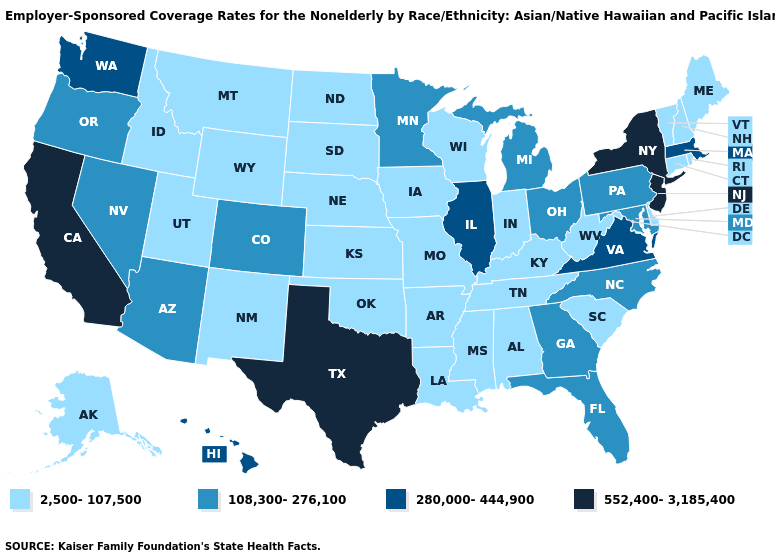Name the states that have a value in the range 108,300-276,100?
Concise answer only. Arizona, Colorado, Florida, Georgia, Maryland, Michigan, Minnesota, Nevada, North Carolina, Ohio, Oregon, Pennsylvania. Name the states that have a value in the range 280,000-444,900?
Write a very short answer. Hawaii, Illinois, Massachusetts, Virginia, Washington. What is the value of Maine?
Concise answer only. 2,500-107,500. What is the highest value in the USA?
Answer briefly. 552,400-3,185,400. What is the value of Montana?
Answer briefly. 2,500-107,500. Does Texas have the highest value in the USA?
Be succinct. Yes. Among the states that border Connecticut , which have the highest value?
Write a very short answer. New York. Does Washington have a lower value than New York?
Concise answer only. Yes. Name the states that have a value in the range 280,000-444,900?
Concise answer only. Hawaii, Illinois, Massachusetts, Virginia, Washington. Name the states that have a value in the range 2,500-107,500?
Concise answer only. Alabama, Alaska, Arkansas, Connecticut, Delaware, Idaho, Indiana, Iowa, Kansas, Kentucky, Louisiana, Maine, Mississippi, Missouri, Montana, Nebraska, New Hampshire, New Mexico, North Dakota, Oklahoma, Rhode Island, South Carolina, South Dakota, Tennessee, Utah, Vermont, West Virginia, Wisconsin, Wyoming. Does Tennessee have a lower value than Texas?
Short answer required. Yes. Does the map have missing data?
Quick response, please. No. Does Wyoming have the lowest value in the West?
Be succinct. Yes. Among the states that border Nevada , does Utah have the lowest value?
Quick response, please. Yes. Name the states that have a value in the range 108,300-276,100?
Answer briefly. Arizona, Colorado, Florida, Georgia, Maryland, Michigan, Minnesota, Nevada, North Carolina, Ohio, Oregon, Pennsylvania. 